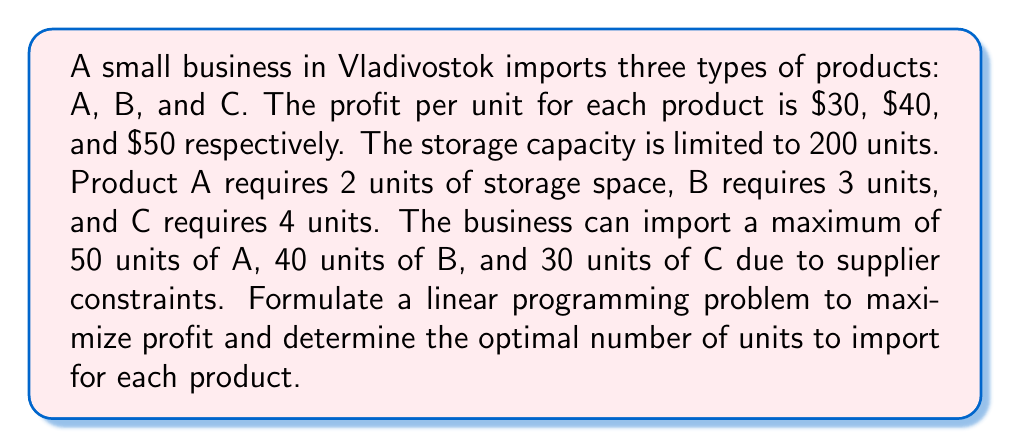Provide a solution to this math problem. Let's approach this step-by-step:

1) Define variables:
   Let $x$, $y$, and $z$ be the number of units of products A, B, and C respectively.

2) Objective function:
   Maximize profit: $P = 30x + 40y + 50z$

3) Constraints:
   a) Storage constraint: $2x + 3y + 4z \leq 200$
   b) Supplier constraints: $x \leq 50$, $y \leq 40$, $z \leq 30$
   c) Non-negativity: $x, y, z \geq 0$

4) Complete linear programming formulation:

   Maximize $P = 30x + 40y + 50z$
   Subject to:
   $$\begin{align}
   2x + 3y + 4z &\leq 200 \\
   x &\leq 50 \\
   y &\leq 40 \\
   z &\leq 30 \\
   x, y, z &\geq 0
   \end{align}$$

5) To solve this, we can use the simplex method or linear programming software. However, we can also reason about the optimal solution:

   - Product C has the highest profit per unit and should be prioritized.
   - We can import 30 units of C (its maximum), using 120 storage units.
   - We have 80 storage units left, which can accommodate 26 units of B.
   - The remaining 2 storage units can accommodate 1 unit of A.

6) Therefore, the optimal solution is:
   $x = 1$, $y = 26$, $z = 30$

7) The maximum profit is:
   $P = 30(1) + 40(26) + 50(30) = 2570$
Answer: $x = 1$, $y = 26$, $z = 30$; Maximum profit = $2570 